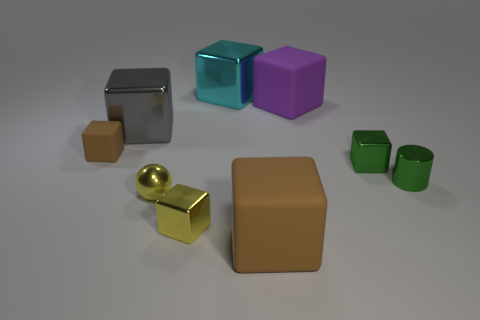How many cylinders are the same color as the small matte block?
Your answer should be very brief. 0. There is a ball; are there any small blocks behind it?
Your response must be concise. Yes. Is the number of gray blocks right of the cylinder the same as the number of tiny metal cubes that are in front of the yellow sphere?
Make the answer very short. No. Do the brown thing behind the big brown thing and the block that is in front of the tiny yellow cube have the same size?
Offer a terse response. No. There is a tiny green metallic object that is to the right of the small cube on the right side of the big rubber block in front of the small brown block; what is its shape?
Offer a terse response. Cylinder. Is there anything else that is made of the same material as the large gray thing?
Provide a succinct answer. Yes. What is the size of the gray shiny thing that is the same shape as the purple matte object?
Offer a very short reply. Large. There is a metallic block that is left of the large cyan metal block and behind the small shiny sphere; what is its color?
Provide a succinct answer. Gray. Does the tiny cylinder have the same material as the brown cube in front of the yellow metallic ball?
Offer a very short reply. No. Is the number of big brown rubber objects that are left of the cyan shiny object less than the number of balls?
Provide a short and direct response. Yes. 